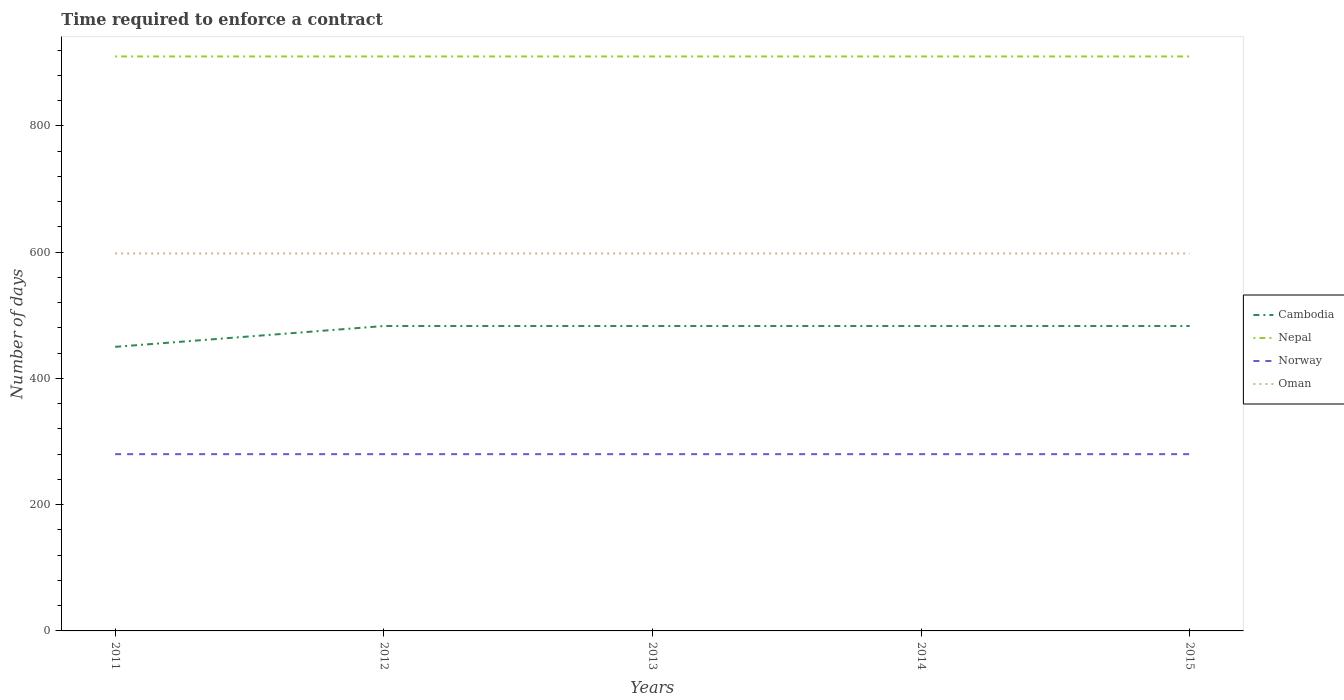Is the number of lines equal to the number of legend labels?
Give a very brief answer. Yes. Across all years, what is the maximum number of days required to enforce a contract in Nepal?
Offer a terse response. 910. In which year was the number of days required to enforce a contract in Nepal maximum?
Your answer should be very brief. 2011. What is the total number of days required to enforce a contract in Cambodia in the graph?
Offer a very short reply. -33. What is the difference between the highest and the second highest number of days required to enforce a contract in Cambodia?
Offer a very short reply. 33. How many lines are there?
Offer a very short reply. 4. Does the graph contain any zero values?
Your answer should be compact. No. Does the graph contain grids?
Make the answer very short. No. Where does the legend appear in the graph?
Provide a succinct answer. Center right. How many legend labels are there?
Your response must be concise. 4. How are the legend labels stacked?
Provide a succinct answer. Vertical. What is the title of the graph?
Keep it short and to the point. Time required to enforce a contract. Does "High income" appear as one of the legend labels in the graph?
Give a very brief answer. No. What is the label or title of the Y-axis?
Your answer should be very brief. Number of days. What is the Number of days in Cambodia in 2011?
Ensure brevity in your answer.  450. What is the Number of days of Nepal in 2011?
Make the answer very short. 910. What is the Number of days in Norway in 2011?
Offer a very short reply. 280. What is the Number of days of Oman in 2011?
Offer a very short reply. 598. What is the Number of days in Cambodia in 2012?
Keep it short and to the point. 483. What is the Number of days of Nepal in 2012?
Provide a succinct answer. 910. What is the Number of days in Norway in 2012?
Your answer should be very brief. 280. What is the Number of days of Oman in 2012?
Provide a short and direct response. 598. What is the Number of days of Cambodia in 2013?
Your answer should be very brief. 483. What is the Number of days of Nepal in 2013?
Your answer should be very brief. 910. What is the Number of days of Norway in 2013?
Your answer should be compact. 280. What is the Number of days in Oman in 2013?
Provide a short and direct response. 598. What is the Number of days of Cambodia in 2014?
Your answer should be very brief. 483. What is the Number of days in Nepal in 2014?
Provide a short and direct response. 910. What is the Number of days of Norway in 2014?
Offer a terse response. 280. What is the Number of days in Oman in 2014?
Your answer should be compact. 598. What is the Number of days of Cambodia in 2015?
Make the answer very short. 483. What is the Number of days in Nepal in 2015?
Provide a short and direct response. 910. What is the Number of days in Norway in 2015?
Your response must be concise. 280. What is the Number of days of Oman in 2015?
Your answer should be compact. 598. Across all years, what is the maximum Number of days in Cambodia?
Your answer should be compact. 483. Across all years, what is the maximum Number of days of Nepal?
Ensure brevity in your answer.  910. Across all years, what is the maximum Number of days of Norway?
Provide a succinct answer. 280. Across all years, what is the maximum Number of days in Oman?
Ensure brevity in your answer.  598. Across all years, what is the minimum Number of days in Cambodia?
Your answer should be very brief. 450. Across all years, what is the minimum Number of days in Nepal?
Give a very brief answer. 910. Across all years, what is the minimum Number of days of Norway?
Your answer should be very brief. 280. Across all years, what is the minimum Number of days of Oman?
Provide a succinct answer. 598. What is the total Number of days in Cambodia in the graph?
Ensure brevity in your answer.  2382. What is the total Number of days of Nepal in the graph?
Your answer should be compact. 4550. What is the total Number of days in Norway in the graph?
Provide a short and direct response. 1400. What is the total Number of days in Oman in the graph?
Offer a terse response. 2990. What is the difference between the Number of days in Cambodia in 2011 and that in 2012?
Your answer should be very brief. -33. What is the difference between the Number of days of Norway in 2011 and that in 2012?
Make the answer very short. 0. What is the difference between the Number of days of Cambodia in 2011 and that in 2013?
Offer a very short reply. -33. What is the difference between the Number of days of Oman in 2011 and that in 2013?
Make the answer very short. 0. What is the difference between the Number of days in Cambodia in 2011 and that in 2014?
Provide a succinct answer. -33. What is the difference between the Number of days of Nepal in 2011 and that in 2014?
Your response must be concise. 0. What is the difference between the Number of days in Cambodia in 2011 and that in 2015?
Your answer should be compact. -33. What is the difference between the Number of days in Norway in 2011 and that in 2015?
Your response must be concise. 0. What is the difference between the Number of days in Cambodia in 2012 and that in 2013?
Make the answer very short. 0. What is the difference between the Number of days of Nepal in 2012 and that in 2013?
Offer a very short reply. 0. What is the difference between the Number of days in Oman in 2012 and that in 2013?
Your answer should be very brief. 0. What is the difference between the Number of days in Norway in 2012 and that in 2014?
Your answer should be very brief. 0. What is the difference between the Number of days in Cambodia in 2012 and that in 2015?
Your answer should be very brief. 0. What is the difference between the Number of days in Nepal in 2012 and that in 2015?
Your answer should be very brief. 0. What is the difference between the Number of days of Norway in 2012 and that in 2015?
Offer a terse response. 0. What is the difference between the Number of days of Nepal in 2013 and that in 2014?
Provide a short and direct response. 0. What is the difference between the Number of days in Norway in 2013 and that in 2014?
Provide a short and direct response. 0. What is the difference between the Number of days in Cambodia in 2013 and that in 2015?
Your answer should be compact. 0. What is the difference between the Number of days of Oman in 2013 and that in 2015?
Offer a terse response. 0. What is the difference between the Number of days of Cambodia in 2014 and that in 2015?
Your answer should be very brief. 0. What is the difference between the Number of days in Nepal in 2014 and that in 2015?
Keep it short and to the point. 0. What is the difference between the Number of days in Cambodia in 2011 and the Number of days in Nepal in 2012?
Your answer should be compact. -460. What is the difference between the Number of days in Cambodia in 2011 and the Number of days in Norway in 2012?
Ensure brevity in your answer.  170. What is the difference between the Number of days of Cambodia in 2011 and the Number of days of Oman in 2012?
Make the answer very short. -148. What is the difference between the Number of days in Nepal in 2011 and the Number of days in Norway in 2012?
Provide a succinct answer. 630. What is the difference between the Number of days of Nepal in 2011 and the Number of days of Oman in 2012?
Keep it short and to the point. 312. What is the difference between the Number of days in Norway in 2011 and the Number of days in Oman in 2012?
Your answer should be very brief. -318. What is the difference between the Number of days of Cambodia in 2011 and the Number of days of Nepal in 2013?
Offer a terse response. -460. What is the difference between the Number of days of Cambodia in 2011 and the Number of days of Norway in 2013?
Provide a short and direct response. 170. What is the difference between the Number of days in Cambodia in 2011 and the Number of days in Oman in 2013?
Give a very brief answer. -148. What is the difference between the Number of days of Nepal in 2011 and the Number of days of Norway in 2013?
Offer a terse response. 630. What is the difference between the Number of days of Nepal in 2011 and the Number of days of Oman in 2013?
Your response must be concise. 312. What is the difference between the Number of days of Norway in 2011 and the Number of days of Oman in 2013?
Offer a terse response. -318. What is the difference between the Number of days of Cambodia in 2011 and the Number of days of Nepal in 2014?
Provide a short and direct response. -460. What is the difference between the Number of days of Cambodia in 2011 and the Number of days of Norway in 2014?
Ensure brevity in your answer.  170. What is the difference between the Number of days of Cambodia in 2011 and the Number of days of Oman in 2014?
Your response must be concise. -148. What is the difference between the Number of days of Nepal in 2011 and the Number of days of Norway in 2014?
Keep it short and to the point. 630. What is the difference between the Number of days in Nepal in 2011 and the Number of days in Oman in 2014?
Give a very brief answer. 312. What is the difference between the Number of days of Norway in 2011 and the Number of days of Oman in 2014?
Offer a terse response. -318. What is the difference between the Number of days of Cambodia in 2011 and the Number of days of Nepal in 2015?
Offer a terse response. -460. What is the difference between the Number of days of Cambodia in 2011 and the Number of days of Norway in 2015?
Make the answer very short. 170. What is the difference between the Number of days of Cambodia in 2011 and the Number of days of Oman in 2015?
Make the answer very short. -148. What is the difference between the Number of days of Nepal in 2011 and the Number of days of Norway in 2015?
Keep it short and to the point. 630. What is the difference between the Number of days of Nepal in 2011 and the Number of days of Oman in 2015?
Ensure brevity in your answer.  312. What is the difference between the Number of days in Norway in 2011 and the Number of days in Oman in 2015?
Offer a terse response. -318. What is the difference between the Number of days of Cambodia in 2012 and the Number of days of Nepal in 2013?
Keep it short and to the point. -427. What is the difference between the Number of days in Cambodia in 2012 and the Number of days in Norway in 2013?
Offer a terse response. 203. What is the difference between the Number of days in Cambodia in 2012 and the Number of days in Oman in 2013?
Provide a succinct answer. -115. What is the difference between the Number of days in Nepal in 2012 and the Number of days in Norway in 2013?
Make the answer very short. 630. What is the difference between the Number of days of Nepal in 2012 and the Number of days of Oman in 2013?
Make the answer very short. 312. What is the difference between the Number of days of Norway in 2012 and the Number of days of Oman in 2013?
Give a very brief answer. -318. What is the difference between the Number of days in Cambodia in 2012 and the Number of days in Nepal in 2014?
Provide a succinct answer. -427. What is the difference between the Number of days in Cambodia in 2012 and the Number of days in Norway in 2014?
Your response must be concise. 203. What is the difference between the Number of days of Cambodia in 2012 and the Number of days of Oman in 2014?
Your answer should be compact. -115. What is the difference between the Number of days in Nepal in 2012 and the Number of days in Norway in 2014?
Provide a short and direct response. 630. What is the difference between the Number of days in Nepal in 2012 and the Number of days in Oman in 2014?
Provide a short and direct response. 312. What is the difference between the Number of days of Norway in 2012 and the Number of days of Oman in 2014?
Offer a very short reply. -318. What is the difference between the Number of days of Cambodia in 2012 and the Number of days of Nepal in 2015?
Provide a short and direct response. -427. What is the difference between the Number of days of Cambodia in 2012 and the Number of days of Norway in 2015?
Your answer should be very brief. 203. What is the difference between the Number of days in Cambodia in 2012 and the Number of days in Oman in 2015?
Offer a terse response. -115. What is the difference between the Number of days in Nepal in 2012 and the Number of days in Norway in 2015?
Your answer should be very brief. 630. What is the difference between the Number of days in Nepal in 2012 and the Number of days in Oman in 2015?
Ensure brevity in your answer.  312. What is the difference between the Number of days of Norway in 2012 and the Number of days of Oman in 2015?
Make the answer very short. -318. What is the difference between the Number of days of Cambodia in 2013 and the Number of days of Nepal in 2014?
Make the answer very short. -427. What is the difference between the Number of days of Cambodia in 2013 and the Number of days of Norway in 2014?
Provide a succinct answer. 203. What is the difference between the Number of days in Cambodia in 2013 and the Number of days in Oman in 2014?
Provide a succinct answer. -115. What is the difference between the Number of days of Nepal in 2013 and the Number of days of Norway in 2014?
Offer a terse response. 630. What is the difference between the Number of days in Nepal in 2013 and the Number of days in Oman in 2014?
Make the answer very short. 312. What is the difference between the Number of days in Norway in 2013 and the Number of days in Oman in 2014?
Your answer should be compact. -318. What is the difference between the Number of days in Cambodia in 2013 and the Number of days in Nepal in 2015?
Offer a terse response. -427. What is the difference between the Number of days of Cambodia in 2013 and the Number of days of Norway in 2015?
Ensure brevity in your answer.  203. What is the difference between the Number of days of Cambodia in 2013 and the Number of days of Oman in 2015?
Your answer should be compact. -115. What is the difference between the Number of days in Nepal in 2013 and the Number of days in Norway in 2015?
Your answer should be compact. 630. What is the difference between the Number of days in Nepal in 2013 and the Number of days in Oman in 2015?
Keep it short and to the point. 312. What is the difference between the Number of days of Norway in 2013 and the Number of days of Oman in 2015?
Offer a terse response. -318. What is the difference between the Number of days in Cambodia in 2014 and the Number of days in Nepal in 2015?
Provide a succinct answer. -427. What is the difference between the Number of days of Cambodia in 2014 and the Number of days of Norway in 2015?
Offer a very short reply. 203. What is the difference between the Number of days in Cambodia in 2014 and the Number of days in Oman in 2015?
Keep it short and to the point. -115. What is the difference between the Number of days in Nepal in 2014 and the Number of days in Norway in 2015?
Give a very brief answer. 630. What is the difference between the Number of days of Nepal in 2014 and the Number of days of Oman in 2015?
Provide a short and direct response. 312. What is the difference between the Number of days in Norway in 2014 and the Number of days in Oman in 2015?
Make the answer very short. -318. What is the average Number of days in Cambodia per year?
Your response must be concise. 476.4. What is the average Number of days of Nepal per year?
Ensure brevity in your answer.  910. What is the average Number of days of Norway per year?
Your answer should be compact. 280. What is the average Number of days of Oman per year?
Your answer should be compact. 598. In the year 2011, what is the difference between the Number of days of Cambodia and Number of days of Nepal?
Offer a terse response. -460. In the year 2011, what is the difference between the Number of days of Cambodia and Number of days of Norway?
Give a very brief answer. 170. In the year 2011, what is the difference between the Number of days in Cambodia and Number of days in Oman?
Your answer should be compact. -148. In the year 2011, what is the difference between the Number of days of Nepal and Number of days of Norway?
Make the answer very short. 630. In the year 2011, what is the difference between the Number of days of Nepal and Number of days of Oman?
Offer a terse response. 312. In the year 2011, what is the difference between the Number of days in Norway and Number of days in Oman?
Your answer should be very brief. -318. In the year 2012, what is the difference between the Number of days in Cambodia and Number of days in Nepal?
Your answer should be very brief. -427. In the year 2012, what is the difference between the Number of days of Cambodia and Number of days of Norway?
Give a very brief answer. 203. In the year 2012, what is the difference between the Number of days in Cambodia and Number of days in Oman?
Keep it short and to the point. -115. In the year 2012, what is the difference between the Number of days in Nepal and Number of days in Norway?
Give a very brief answer. 630. In the year 2012, what is the difference between the Number of days of Nepal and Number of days of Oman?
Your answer should be very brief. 312. In the year 2012, what is the difference between the Number of days of Norway and Number of days of Oman?
Provide a short and direct response. -318. In the year 2013, what is the difference between the Number of days of Cambodia and Number of days of Nepal?
Offer a terse response. -427. In the year 2013, what is the difference between the Number of days of Cambodia and Number of days of Norway?
Your answer should be compact. 203. In the year 2013, what is the difference between the Number of days of Cambodia and Number of days of Oman?
Keep it short and to the point. -115. In the year 2013, what is the difference between the Number of days of Nepal and Number of days of Norway?
Provide a short and direct response. 630. In the year 2013, what is the difference between the Number of days in Nepal and Number of days in Oman?
Make the answer very short. 312. In the year 2013, what is the difference between the Number of days in Norway and Number of days in Oman?
Your answer should be compact. -318. In the year 2014, what is the difference between the Number of days of Cambodia and Number of days of Nepal?
Ensure brevity in your answer.  -427. In the year 2014, what is the difference between the Number of days in Cambodia and Number of days in Norway?
Provide a succinct answer. 203. In the year 2014, what is the difference between the Number of days in Cambodia and Number of days in Oman?
Provide a short and direct response. -115. In the year 2014, what is the difference between the Number of days in Nepal and Number of days in Norway?
Your answer should be very brief. 630. In the year 2014, what is the difference between the Number of days of Nepal and Number of days of Oman?
Your answer should be compact. 312. In the year 2014, what is the difference between the Number of days of Norway and Number of days of Oman?
Make the answer very short. -318. In the year 2015, what is the difference between the Number of days of Cambodia and Number of days of Nepal?
Provide a succinct answer. -427. In the year 2015, what is the difference between the Number of days of Cambodia and Number of days of Norway?
Provide a short and direct response. 203. In the year 2015, what is the difference between the Number of days in Cambodia and Number of days in Oman?
Ensure brevity in your answer.  -115. In the year 2015, what is the difference between the Number of days in Nepal and Number of days in Norway?
Your response must be concise. 630. In the year 2015, what is the difference between the Number of days in Nepal and Number of days in Oman?
Your answer should be compact. 312. In the year 2015, what is the difference between the Number of days of Norway and Number of days of Oman?
Your answer should be very brief. -318. What is the ratio of the Number of days of Cambodia in 2011 to that in 2012?
Your answer should be compact. 0.93. What is the ratio of the Number of days of Nepal in 2011 to that in 2012?
Give a very brief answer. 1. What is the ratio of the Number of days of Norway in 2011 to that in 2012?
Keep it short and to the point. 1. What is the ratio of the Number of days of Oman in 2011 to that in 2012?
Offer a very short reply. 1. What is the ratio of the Number of days of Cambodia in 2011 to that in 2013?
Give a very brief answer. 0.93. What is the ratio of the Number of days of Nepal in 2011 to that in 2013?
Your response must be concise. 1. What is the ratio of the Number of days of Norway in 2011 to that in 2013?
Your answer should be very brief. 1. What is the ratio of the Number of days of Oman in 2011 to that in 2013?
Provide a short and direct response. 1. What is the ratio of the Number of days in Cambodia in 2011 to that in 2014?
Your response must be concise. 0.93. What is the ratio of the Number of days of Nepal in 2011 to that in 2014?
Make the answer very short. 1. What is the ratio of the Number of days of Oman in 2011 to that in 2014?
Give a very brief answer. 1. What is the ratio of the Number of days of Cambodia in 2011 to that in 2015?
Keep it short and to the point. 0.93. What is the ratio of the Number of days in Nepal in 2011 to that in 2015?
Provide a short and direct response. 1. What is the ratio of the Number of days in Cambodia in 2012 to that in 2013?
Keep it short and to the point. 1. What is the ratio of the Number of days of Nepal in 2012 to that in 2013?
Give a very brief answer. 1. What is the ratio of the Number of days in Oman in 2012 to that in 2013?
Give a very brief answer. 1. What is the ratio of the Number of days in Nepal in 2012 to that in 2014?
Make the answer very short. 1. What is the ratio of the Number of days in Norway in 2012 to that in 2014?
Offer a very short reply. 1. What is the ratio of the Number of days of Cambodia in 2012 to that in 2015?
Make the answer very short. 1. What is the ratio of the Number of days of Nepal in 2012 to that in 2015?
Give a very brief answer. 1. What is the ratio of the Number of days in Norway in 2012 to that in 2015?
Give a very brief answer. 1. What is the ratio of the Number of days in Oman in 2012 to that in 2015?
Your answer should be very brief. 1. What is the ratio of the Number of days in Cambodia in 2013 to that in 2014?
Your answer should be very brief. 1. What is the ratio of the Number of days of Nepal in 2013 to that in 2014?
Ensure brevity in your answer.  1. What is the ratio of the Number of days in Cambodia in 2013 to that in 2015?
Your answer should be very brief. 1. What is the ratio of the Number of days of Oman in 2013 to that in 2015?
Keep it short and to the point. 1. What is the ratio of the Number of days of Cambodia in 2014 to that in 2015?
Ensure brevity in your answer.  1. What is the ratio of the Number of days of Norway in 2014 to that in 2015?
Your answer should be very brief. 1. What is the ratio of the Number of days of Oman in 2014 to that in 2015?
Provide a short and direct response. 1. What is the difference between the highest and the second highest Number of days in Cambodia?
Provide a succinct answer. 0. What is the difference between the highest and the second highest Number of days in Nepal?
Give a very brief answer. 0. What is the difference between the highest and the second highest Number of days of Norway?
Provide a succinct answer. 0. What is the difference between the highest and the lowest Number of days in Oman?
Your answer should be very brief. 0. 